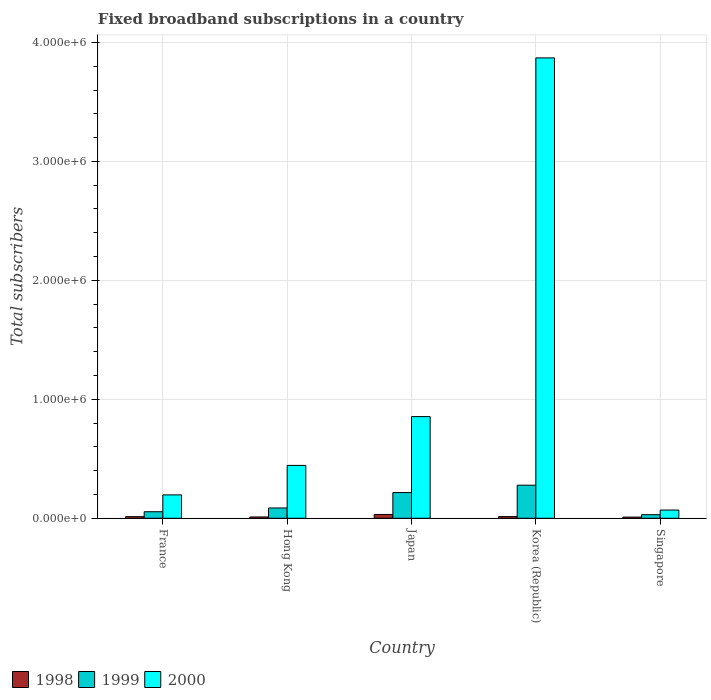How many groups of bars are there?
Keep it short and to the point. 5. Are the number of bars per tick equal to the number of legend labels?
Make the answer very short. Yes. How many bars are there on the 3rd tick from the left?
Your answer should be very brief. 3. How many bars are there on the 2nd tick from the right?
Offer a terse response. 3. What is the label of the 2nd group of bars from the left?
Provide a succinct answer. Hong Kong. What is the number of broadband subscriptions in 1998 in Korea (Republic)?
Make the answer very short. 1.40e+04. Across all countries, what is the maximum number of broadband subscriptions in 1998?
Offer a terse response. 3.20e+04. Across all countries, what is the minimum number of broadband subscriptions in 1999?
Provide a succinct answer. 3.00e+04. In which country was the number of broadband subscriptions in 2000 minimum?
Your response must be concise. Singapore. What is the total number of broadband subscriptions in 1999 in the graph?
Offer a terse response. 6.65e+05. What is the difference between the number of broadband subscriptions in 2000 in France and that in Singapore?
Offer a very short reply. 1.28e+05. What is the difference between the number of broadband subscriptions in 1999 in Singapore and the number of broadband subscriptions in 1998 in Japan?
Provide a short and direct response. -2000. What is the average number of broadband subscriptions in 2000 per country?
Your response must be concise. 1.09e+06. What is the difference between the number of broadband subscriptions of/in 1999 and number of broadband subscriptions of/in 2000 in Singapore?
Ensure brevity in your answer.  -3.90e+04. What is the ratio of the number of broadband subscriptions in 1998 in France to that in Korea (Republic)?
Give a very brief answer. 0.96. What is the difference between the highest and the second highest number of broadband subscriptions in 1998?
Offer a very short reply. 1.85e+04. What is the difference between the highest and the lowest number of broadband subscriptions in 2000?
Your response must be concise. 3.80e+06. In how many countries, is the number of broadband subscriptions in 1998 greater than the average number of broadband subscriptions in 1998 taken over all countries?
Offer a very short reply. 1. What does the 1st bar from the left in France represents?
Give a very brief answer. 1998. What does the 2nd bar from the right in Korea (Republic) represents?
Offer a very short reply. 1999. What is the difference between two consecutive major ticks on the Y-axis?
Make the answer very short. 1.00e+06. Does the graph contain grids?
Your answer should be very brief. Yes. How are the legend labels stacked?
Provide a short and direct response. Horizontal. What is the title of the graph?
Keep it short and to the point. Fixed broadband subscriptions in a country. What is the label or title of the X-axis?
Your answer should be compact. Country. What is the label or title of the Y-axis?
Offer a very short reply. Total subscribers. What is the Total subscribers in 1998 in France?
Keep it short and to the point. 1.35e+04. What is the Total subscribers in 1999 in France?
Give a very brief answer. 5.50e+04. What is the Total subscribers of 2000 in France?
Your answer should be very brief. 1.97e+05. What is the Total subscribers in 1998 in Hong Kong?
Your answer should be compact. 1.10e+04. What is the Total subscribers of 1999 in Hong Kong?
Provide a short and direct response. 8.65e+04. What is the Total subscribers of 2000 in Hong Kong?
Offer a terse response. 4.44e+05. What is the Total subscribers of 1998 in Japan?
Give a very brief answer. 3.20e+04. What is the Total subscribers of 1999 in Japan?
Your answer should be very brief. 2.16e+05. What is the Total subscribers of 2000 in Japan?
Make the answer very short. 8.55e+05. What is the Total subscribers in 1998 in Korea (Republic)?
Your response must be concise. 1.40e+04. What is the Total subscribers in 1999 in Korea (Republic)?
Your response must be concise. 2.78e+05. What is the Total subscribers of 2000 in Korea (Republic)?
Make the answer very short. 3.87e+06. What is the Total subscribers of 1998 in Singapore?
Offer a very short reply. 10000. What is the Total subscribers of 2000 in Singapore?
Keep it short and to the point. 6.90e+04. Across all countries, what is the maximum Total subscribers of 1998?
Provide a short and direct response. 3.20e+04. Across all countries, what is the maximum Total subscribers in 1999?
Provide a succinct answer. 2.78e+05. Across all countries, what is the maximum Total subscribers of 2000?
Offer a very short reply. 3.87e+06. Across all countries, what is the minimum Total subscribers in 2000?
Ensure brevity in your answer.  6.90e+04. What is the total Total subscribers in 1998 in the graph?
Give a very brief answer. 8.05e+04. What is the total Total subscribers in 1999 in the graph?
Provide a succinct answer. 6.65e+05. What is the total Total subscribers in 2000 in the graph?
Ensure brevity in your answer.  5.43e+06. What is the difference between the Total subscribers in 1998 in France and that in Hong Kong?
Your answer should be compact. 2464. What is the difference between the Total subscribers in 1999 in France and that in Hong Kong?
Your response must be concise. -3.15e+04. What is the difference between the Total subscribers in 2000 in France and that in Hong Kong?
Provide a succinct answer. -2.48e+05. What is the difference between the Total subscribers of 1998 in France and that in Japan?
Give a very brief answer. -1.85e+04. What is the difference between the Total subscribers in 1999 in France and that in Japan?
Your answer should be compact. -1.61e+05. What is the difference between the Total subscribers of 2000 in France and that in Japan?
Provide a short and direct response. -6.58e+05. What is the difference between the Total subscribers of 1998 in France and that in Korea (Republic)?
Your response must be concise. -536. What is the difference between the Total subscribers of 1999 in France and that in Korea (Republic)?
Offer a very short reply. -2.23e+05. What is the difference between the Total subscribers of 2000 in France and that in Korea (Republic)?
Make the answer very short. -3.67e+06. What is the difference between the Total subscribers of 1998 in France and that in Singapore?
Provide a short and direct response. 3464. What is the difference between the Total subscribers of 1999 in France and that in Singapore?
Offer a terse response. 2.50e+04. What is the difference between the Total subscribers of 2000 in France and that in Singapore?
Offer a terse response. 1.28e+05. What is the difference between the Total subscribers of 1998 in Hong Kong and that in Japan?
Give a very brief answer. -2.10e+04. What is the difference between the Total subscribers of 1999 in Hong Kong and that in Japan?
Your answer should be compact. -1.30e+05. What is the difference between the Total subscribers of 2000 in Hong Kong and that in Japan?
Keep it short and to the point. -4.10e+05. What is the difference between the Total subscribers of 1998 in Hong Kong and that in Korea (Republic)?
Your response must be concise. -3000. What is the difference between the Total subscribers of 1999 in Hong Kong and that in Korea (Republic)?
Provide a short and direct response. -1.92e+05. What is the difference between the Total subscribers of 2000 in Hong Kong and that in Korea (Republic)?
Provide a short and direct response. -3.43e+06. What is the difference between the Total subscribers of 1999 in Hong Kong and that in Singapore?
Make the answer very short. 5.65e+04. What is the difference between the Total subscribers in 2000 in Hong Kong and that in Singapore?
Offer a very short reply. 3.75e+05. What is the difference between the Total subscribers of 1998 in Japan and that in Korea (Republic)?
Offer a terse response. 1.80e+04. What is the difference between the Total subscribers in 1999 in Japan and that in Korea (Republic)?
Make the answer very short. -6.20e+04. What is the difference between the Total subscribers of 2000 in Japan and that in Korea (Republic)?
Give a very brief answer. -3.02e+06. What is the difference between the Total subscribers of 1998 in Japan and that in Singapore?
Provide a short and direct response. 2.20e+04. What is the difference between the Total subscribers in 1999 in Japan and that in Singapore?
Your answer should be compact. 1.86e+05. What is the difference between the Total subscribers in 2000 in Japan and that in Singapore?
Ensure brevity in your answer.  7.86e+05. What is the difference between the Total subscribers of 1998 in Korea (Republic) and that in Singapore?
Your response must be concise. 4000. What is the difference between the Total subscribers of 1999 in Korea (Republic) and that in Singapore?
Keep it short and to the point. 2.48e+05. What is the difference between the Total subscribers of 2000 in Korea (Republic) and that in Singapore?
Provide a short and direct response. 3.80e+06. What is the difference between the Total subscribers of 1998 in France and the Total subscribers of 1999 in Hong Kong?
Ensure brevity in your answer.  -7.30e+04. What is the difference between the Total subscribers of 1998 in France and the Total subscribers of 2000 in Hong Kong?
Offer a very short reply. -4.31e+05. What is the difference between the Total subscribers of 1999 in France and the Total subscribers of 2000 in Hong Kong?
Ensure brevity in your answer.  -3.89e+05. What is the difference between the Total subscribers of 1998 in France and the Total subscribers of 1999 in Japan?
Provide a short and direct response. -2.03e+05. What is the difference between the Total subscribers of 1998 in France and the Total subscribers of 2000 in Japan?
Offer a terse response. -8.41e+05. What is the difference between the Total subscribers in 1999 in France and the Total subscribers in 2000 in Japan?
Keep it short and to the point. -8.00e+05. What is the difference between the Total subscribers of 1998 in France and the Total subscribers of 1999 in Korea (Republic)?
Your answer should be very brief. -2.65e+05. What is the difference between the Total subscribers of 1998 in France and the Total subscribers of 2000 in Korea (Republic)?
Offer a terse response. -3.86e+06. What is the difference between the Total subscribers of 1999 in France and the Total subscribers of 2000 in Korea (Republic)?
Ensure brevity in your answer.  -3.82e+06. What is the difference between the Total subscribers in 1998 in France and the Total subscribers in 1999 in Singapore?
Ensure brevity in your answer.  -1.65e+04. What is the difference between the Total subscribers in 1998 in France and the Total subscribers in 2000 in Singapore?
Provide a succinct answer. -5.55e+04. What is the difference between the Total subscribers in 1999 in France and the Total subscribers in 2000 in Singapore?
Give a very brief answer. -1.40e+04. What is the difference between the Total subscribers of 1998 in Hong Kong and the Total subscribers of 1999 in Japan?
Offer a terse response. -2.05e+05. What is the difference between the Total subscribers of 1998 in Hong Kong and the Total subscribers of 2000 in Japan?
Ensure brevity in your answer.  -8.44e+05. What is the difference between the Total subscribers of 1999 in Hong Kong and the Total subscribers of 2000 in Japan?
Provide a succinct answer. -7.68e+05. What is the difference between the Total subscribers in 1998 in Hong Kong and the Total subscribers in 1999 in Korea (Republic)?
Give a very brief answer. -2.67e+05. What is the difference between the Total subscribers in 1998 in Hong Kong and the Total subscribers in 2000 in Korea (Republic)?
Ensure brevity in your answer.  -3.86e+06. What is the difference between the Total subscribers of 1999 in Hong Kong and the Total subscribers of 2000 in Korea (Republic)?
Your answer should be very brief. -3.78e+06. What is the difference between the Total subscribers of 1998 in Hong Kong and the Total subscribers of 1999 in Singapore?
Offer a very short reply. -1.90e+04. What is the difference between the Total subscribers in 1998 in Hong Kong and the Total subscribers in 2000 in Singapore?
Ensure brevity in your answer.  -5.80e+04. What is the difference between the Total subscribers of 1999 in Hong Kong and the Total subscribers of 2000 in Singapore?
Your answer should be very brief. 1.75e+04. What is the difference between the Total subscribers of 1998 in Japan and the Total subscribers of 1999 in Korea (Republic)?
Provide a short and direct response. -2.46e+05. What is the difference between the Total subscribers in 1998 in Japan and the Total subscribers in 2000 in Korea (Republic)?
Your answer should be very brief. -3.84e+06. What is the difference between the Total subscribers in 1999 in Japan and the Total subscribers in 2000 in Korea (Republic)?
Your answer should be very brief. -3.65e+06. What is the difference between the Total subscribers in 1998 in Japan and the Total subscribers in 2000 in Singapore?
Provide a succinct answer. -3.70e+04. What is the difference between the Total subscribers in 1999 in Japan and the Total subscribers in 2000 in Singapore?
Keep it short and to the point. 1.47e+05. What is the difference between the Total subscribers of 1998 in Korea (Republic) and the Total subscribers of 1999 in Singapore?
Offer a terse response. -1.60e+04. What is the difference between the Total subscribers of 1998 in Korea (Republic) and the Total subscribers of 2000 in Singapore?
Offer a terse response. -5.50e+04. What is the difference between the Total subscribers in 1999 in Korea (Republic) and the Total subscribers in 2000 in Singapore?
Your answer should be compact. 2.09e+05. What is the average Total subscribers of 1998 per country?
Make the answer very short. 1.61e+04. What is the average Total subscribers of 1999 per country?
Your response must be concise. 1.33e+05. What is the average Total subscribers in 2000 per country?
Give a very brief answer. 1.09e+06. What is the difference between the Total subscribers in 1998 and Total subscribers in 1999 in France?
Give a very brief answer. -4.15e+04. What is the difference between the Total subscribers of 1998 and Total subscribers of 2000 in France?
Provide a short and direct response. -1.83e+05. What is the difference between the Total subscribers of 1999 and Total subscribers of 2000 in France?
Ensure brevity in your answer.  -1.42e+05. What is the difference between the Total subscribers in 1998 and Total subscribers in 1999 in Hong Kong?
Make the answer very short. -7.55e+04. What is the difference between the Total subscribers of 1998 and Total subscribers of 2000 in Hong Kong?
Offer a very short reply. -4.33e+05. What is the difference between the Total subscribers in 1999 and Total subscribers in 2000 in Hong Kong?
Keep it short and to the point. -3.58e+05. What is the difference between the Total subscribers in 1998 and Total subscribers in 1999 in Japan?
Make the answer very short. -1.84e+05. What is the difference between the Total subscribers in 1998 and Total subscribers in 2000 in Japan?
Provide a succinct answer. -8.23e+05. What is the difference between the Total subscribers of 1999 and Total subscribers of 2000 in Japan?
Ensure brevity in your answer.  -6.39e+05. What is the difference between the Total subscribers in 1998 and Total subscribers in 1999 in Korea (Republic)?
Give a very brief answer. -2.64e+05. What is the difference between the Total subscribers of 1998 and Total subscribers of 2000 in Korea (Republic)?
Your response must be concise. -3.86e+06. What is the difference between the Total subscribers in 1999 and Total subscribers in 2000 in Korea (Republic)?
Give a very brief answer. -3.59e+06. What is the difference between the Total subscribers of 1998 and Total subscribers of 2000 in Singapore?
Ensure brevity in your answer.  -5.90e+04. What is the difference between the Total subscribers of 1999 and Total subscribers of 2000 in Singapore?
Your response must be concise. -3.90e+04. What is the ratio of the Total subscribers in 1998 in France to that in Hong Kong?
Ensure brevity in your answer.  1.22. What is the ratio of the Total subscribers in 1999 in France to that in Hong Kong?
Give a very brief answer. 0.64. What is the ratio of the Total subscribers of 2000 in France to that in Hong Kong?
Offer a terse response. 0.44. What is the ratio of the Total subscribers in 1998 in France to that in Japan?
Your answer should be compact. 0.42. What is the ratio of the Total subscribers of 1999 in France to that in Japan?
Give a very brief answer. 0.25. What is the ratio of the Total subscribers of 2000 in France to that in Japan?
Provide a succinct answer. 0.23. What is the ratio of the Total subscribers in 1998 in France to that in Korea (Republic)?
Ensure brevity in your answer.  0.96. What is the ratio of the Total subscribers of 1999 in France to that in Korea (Republic)?
Make the answer very short. 0.2. What is the ratio of the Total subscribers of 2000 in France to that in Korea (Republic)?
Your answer should be very brief. 0.05. What is the ratio of the Total subscribers in 1998 in France to that in Singapore?
Your answer should be compact. 1.35. What is the ratio of the Total subscribers in 1999 in France to that in Singapore?
Offer a terse response. 1.83. What is the ratio of the Total subscribers of 2000 in France to that in Singapore?
Keep it short and to the point. 2.85. What is the ratio of the Total subscribers of 1998 in Hong Kong to that in Japan?
Your response must be concise. 0.34. What is the ratio of the Total subscribers in 1999 in Hong Kong to that in Japan?
Make the answer very short. 0.4. What is the ratio of the Total subscribers in 2000 in Hong Kong to that in Japan?
Provide a succinct answer. 0.52. What is the ratio of the Total subscribers in 1998 in Hong Kong to that in Korea (Republic)?
Make the answer very short. 0.79. What is the ratio of the Total subscribers in 1999 in Hong Kong to that in Korea (Republic)?
Your answer should be very brief. 0.31. What is the ratio of the Total subscribers in 2000 in Hong Kong to that in Korea (Republic)?
Make the answer very short. 0.11. What is the ratio of the Total subscribers of 1999 in Hong Kong to that in Singapore?
Your response must be concise. 2.88. What is the ratio of the Total subscribers of 2000 in Hong Kong to that in Singapore?
Your response must be concise. 6.44. What is the ratio of the Total subscribers in 1998 in Japan to that in Korea (Republic)?
Your response must be concise. 2.29. What is the ratio of the Total subscribers of 1999 in Japan to that in Korea (Republic)?
Your answer should be very brief. 0.78. What is the ratio of the Total subscribers of 2000 in Japan to that in Korea (Republic)?
Make the answer very short. 0.22. What is the ratio of the Total subscribers in 1999 in Japan to that in Singapore?
Your answer should be very brief. 7.2. What is the ratio of the Total subscribers of 2000 in Japan to that in Singapore?
Ensure brevity in your answer.  12.39. What is the ratio of the Total subscribers of 1999 in Korea (Republic) to that in Singapore?
Provide a succinct answer. 9.27. What is the ratio of the Total subscribers of 2000 in Korea (Republic) to that in Singapore?
Keep it short and to the point. 56.09. What is the difference between the highest and the second highest Total subscribers of 1998?
Your response must be concise. 1.80e+04. What is the difference between the highest and the second highest Total subscribers of 1999?
Your answer should be very brief. 6.20e+04. What is the difference between the highest and the second highest Total subscribers of 2000?
Your answer should be very brief. 3.02e+06. What is the difference between the highest and the lowest Total subscribers in 1998?
Provide a short and direct response. 2.20e+04. What is the difference between the highest and the lowest Total subscribers of 1999?
Keep it short and to the point. 2.48e+05. What is the difference between the highest and the lowest Total subscribers in 2000?
Give a very brief answer. 3.80e+06. 